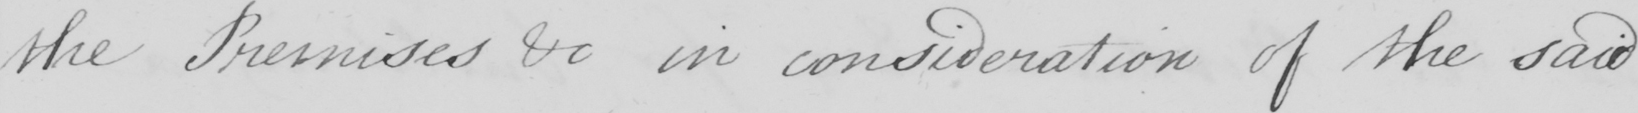Can you read and transcribe this handwriting? the Premises &c in consideration of the said 